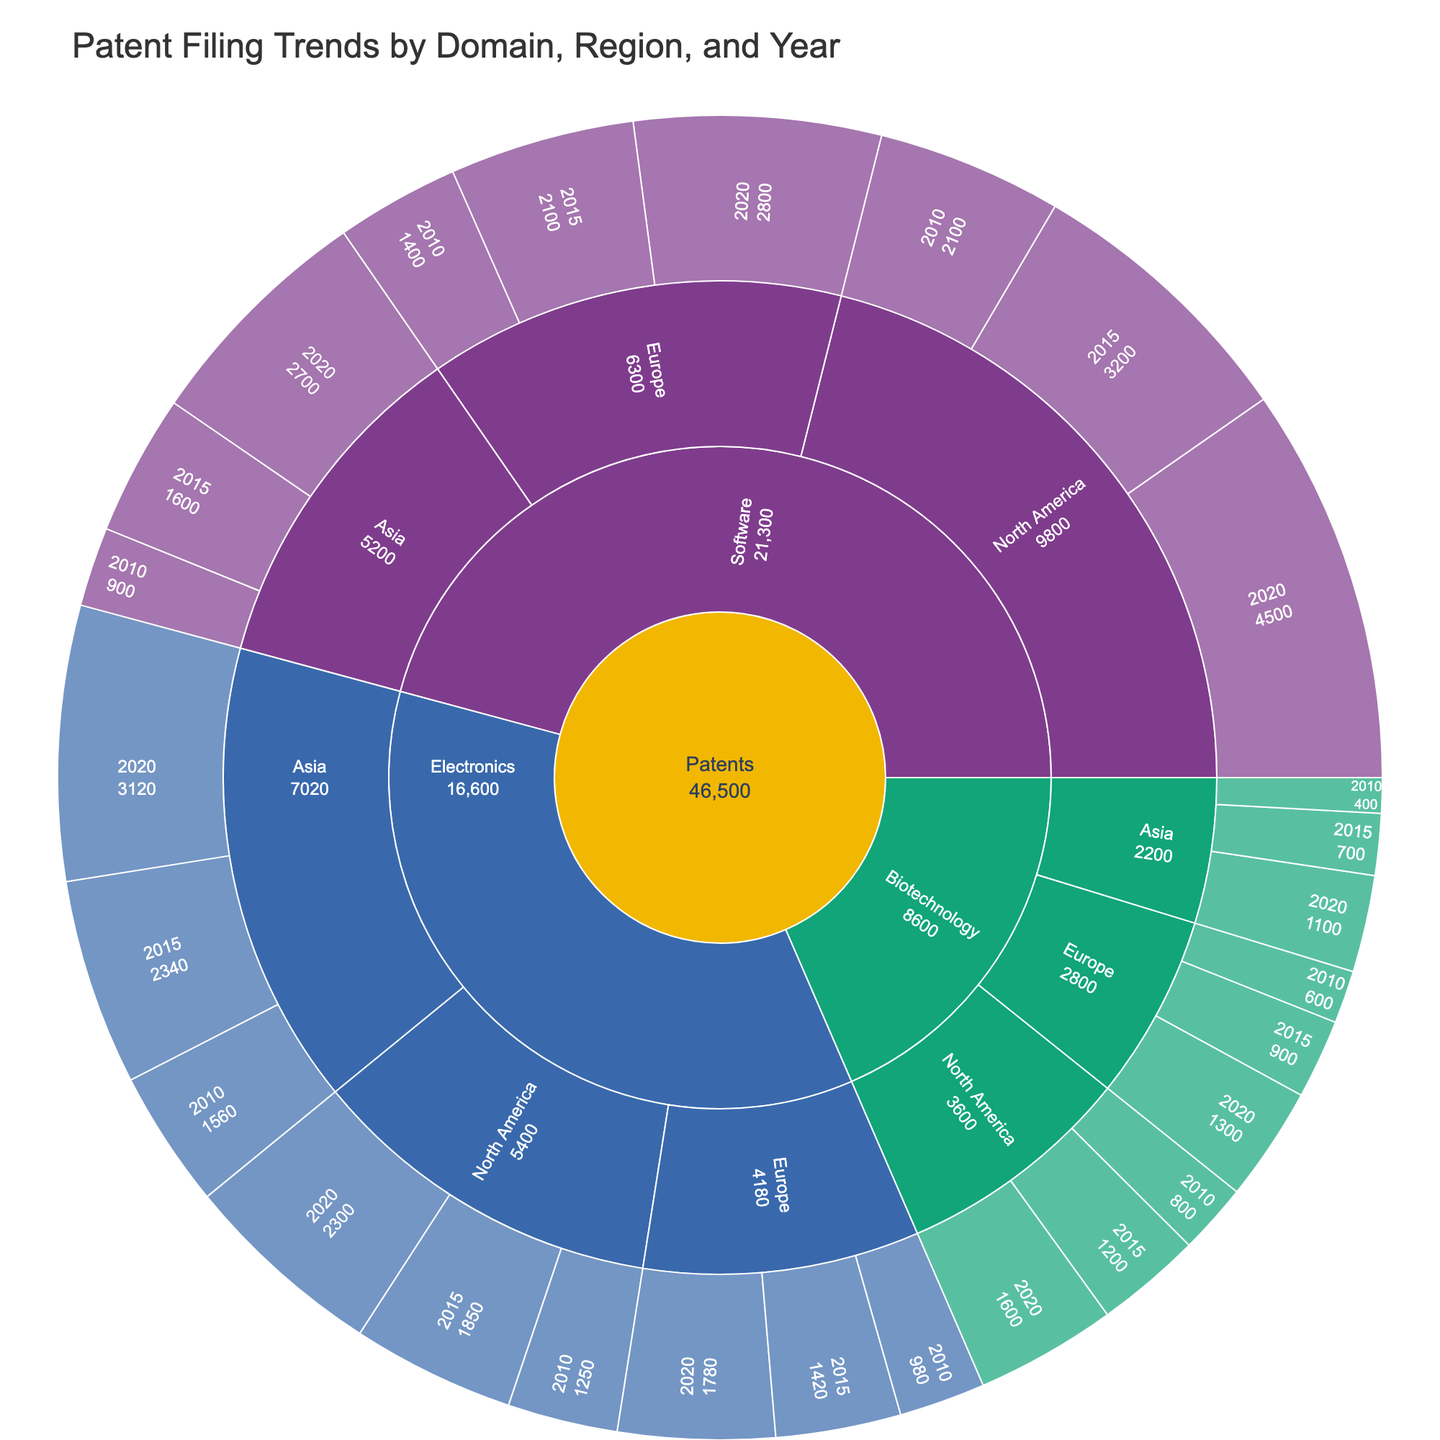What's the title of the sunburst plot? The title is typically displayed at the top of the figure. In this case, the title of the sunburst plot reads "Patent Filing Trends by Domain, Region, and Year".
Answer: Patent Filing Trends by Domain, Region, and Year Which technological domain shows the highest number of patents in 2020? To identify this, look at the outermost ring of the sunburst plot for the year 2020 and compare the segment sizes for each domain. The segment with the greatest size represents the highest number of patents.
Answer: Software Which region within Electronics had the least patent filings in 2010? Examine the segments that fall under the Electronics domain for the year 2010 and see which geographical region has the smallest segment size.
Answer: Europe How did patent filings in North America for Electronics change from 2010 to 2020? Locate the segments for Electronics in North America for the years 2010 and 2020, and compare their sizes to determine the trend. The size increase indicates more filings in 2020 compared to 2010.
Answer: Increased Comparing Europe and Asia in 2020, which region had more software patents filed? Compare the segment sizes corresponding to Europe and Asia in the Software domain for the year 2020. The larger segment size indicates more patents filed.
Answer: Europe What is the total number of patents filed in the Biotechnology domain across all regions in 2010? Sum the patent filings for the Biotechnology domain for each region (North America, Europe, Asia) in the year 2010. These values are 800 (North America) + 600 (Europe) + 400 (Asia) = 1800.
Answer: 1800 In which domain did North America see the highest percentage increase in patent filings from 2010 to 2020? Calculate the percentage increase for each domain in North America. For Electronics: ((2300-1250)/1250)*100 ≈ 84%, for Software: ((4500-2100)/2100)*100 ≈ 114%, and for Biotechnology: ((1600-800)/800)*100 ≈ 100%. Software has the highest increase.
Answer: Software Which region shows a larger increase in patent filings for Biotechnology from 2010 to 2020, North America or Asia? Calculate the numerical increase for both regions. For North America: (1600-800) = 800, and for Asia: (1100-400) = 700. North America has a larger increase.
Answer: North America What proportion of Electronics patents in 2020 were filed in Asia compared to overall Electronics patents filed in 2020? Divide the number of Electronics patents in Asia in 2020 by the total number of Electronics patents filed in 2020. That is, 3120 / (2300 + 1780 + 3120) ≈ 0.41 or 41%.
Answer: 41% Which domain had the most balanced patent filings across regions in 2020? Compare the relative sizes of the segments across North America, Europe, and Asia for each domain for the year 2020. The domain with roughly equal segment sizes across all regions is the most balanced.
Answer: Biotechnology 